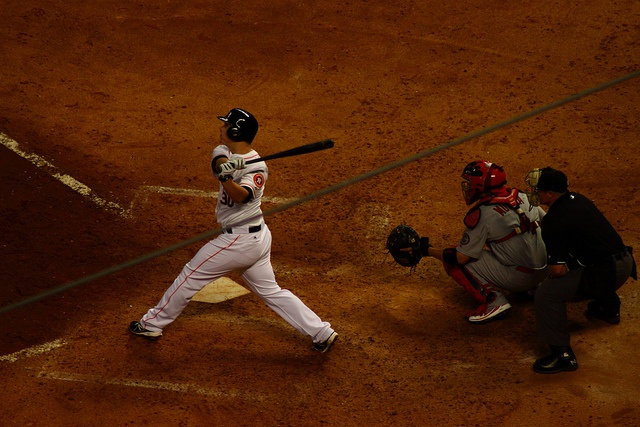Describe the objects in this image and their specific colors. I can see people in maroon, darkgray, black, and gray tones, people in maroon, black, darkgreen, and gray tones, people in maroon, black, and olive tones, baseball glove in maroon, black, and olive tones, and baseball bat in maroon, black, beige, and gray tones in this image. 